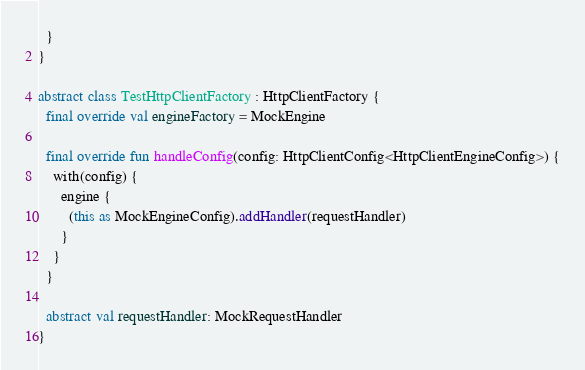Convert code to text. <code><loc_0><loc_0><loc_500><loc_500><_Kotlin_>  }
}

abstract class TestHttpClientFactory : HttpClientFactory {
  final override val engineFactory = MockEngine

  final override fun handleConfig(config: HttpClientConfig<HttpClientEngineConfig>) {
    with(config) {
      engine {
        (this as MockEngineConfig).addHandler(requestHandler)
      }
    }
  }

  abstract val requestHandler: MockRequestHandler
}
</code> 